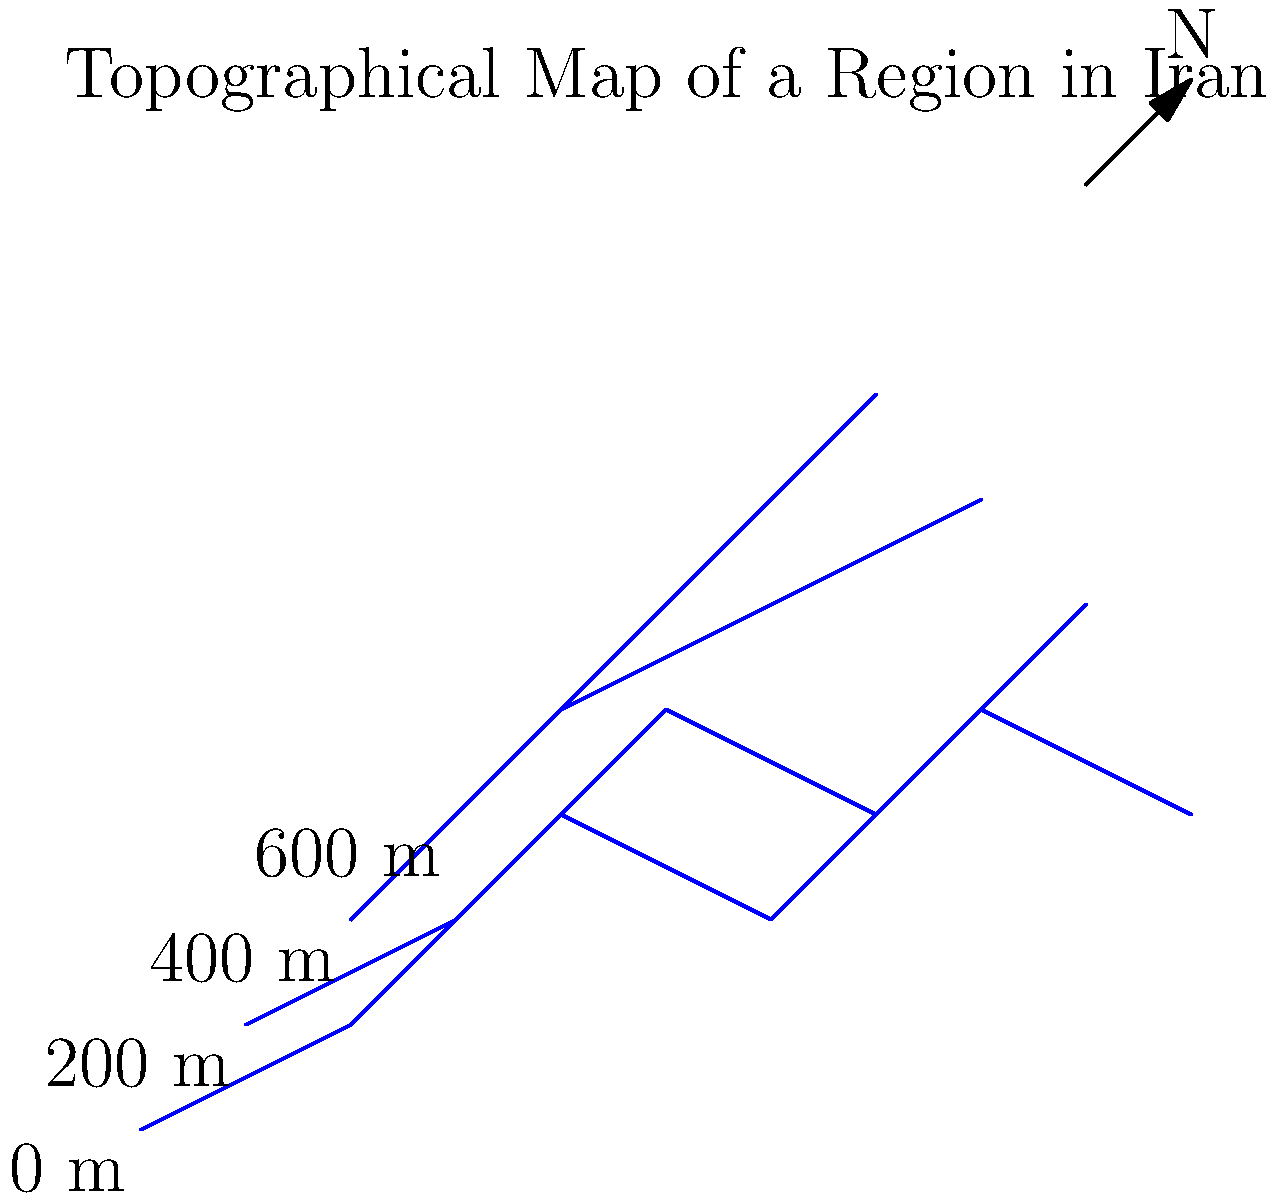Analyze the contour map of a region in Iran. If you were to travel from point A (0,0) to point B (80,60) following the most direct route, how many distinct elevation changes would you encounter? To solve this problem, we need to follow these steps:

1. Identify the starting point A (0,0) and ending point B (80,60) on the map.

2. Visualize the most direct route between these points, which would be approximately a straight line from the bottom-left to the upper-right of the map.

3. Count the number of contour lines this route crosses. Each contour line represents a distinct elevation change.

4. Starting from point A (0,0):
   - We cross the first contour line (0 m to 200 m)
   - Then the second contour line (200 m to 400 m)
   - Next, the third contour line (400 m to 600 m)
   - Finally, we cross the fourth contour line (returning to 400 m)

5. Note that after crossing the highest elevation, we descend, which counts as another distinct elevation change.

Therefore, traveling from point A to point B, we encounter 4 distinct elevation changes: ascending three times and descending once.

This analysis showcases the diverse topography of Iran, highlighting the importance of understanding our nation's varied landscapes for purposes of national unity and strategic planning.
Answer: 4 elevation changes 